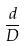Convert formula to latex. <formula><loc_0><loc_0><loc_500><loc_500>\frac { d } { D }</formula> 